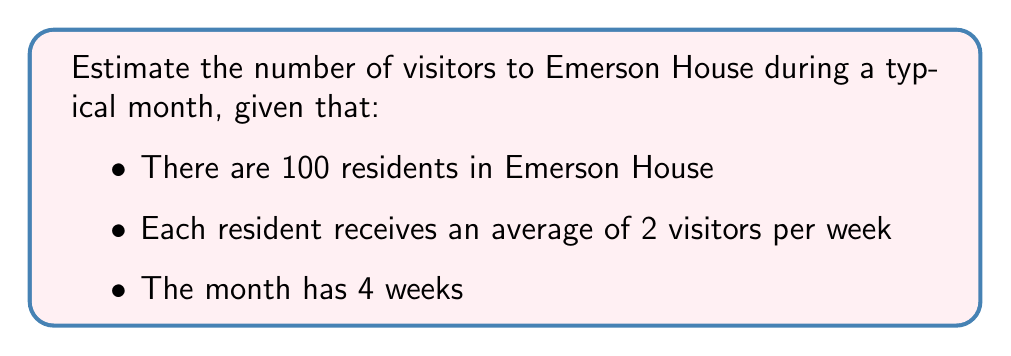Teach me how to tackle this problem. Let's approach this step-by-step:

1. First, we need to calculate the number of visitors per resident per month:
   - Each resident receives 2 visitors per week
   - There are 4 weeks in a month
   - So, visitors per resident per month = $2 \times 4 = 8$

2. Now, we can calculate the total number of visitors for all residents:
   - Number of residents = 100
   - Visitors per resident per month = 8
   - Total visitors = $100 \times 8 = 800$

Therefore, we can estimate that Emerson House receives approximately 800 visitors during a typical month.

This can be represented mathematically as:

$$\text{Total Visitors} = \text{Number of Residents} \times \text{Visitors per Resident per Week} \times \text{Weeks in a Month}$$
$$\text{Total Visitors} = 100 \times 2 \times 4 = 800$$
Answer: 800 visitors 